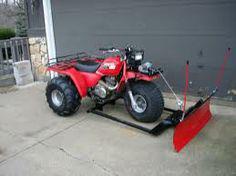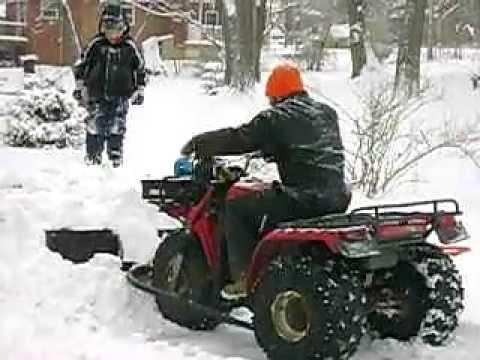The first image is the image on the left, the second image is the image on the right. Evaluate the accuracy of this statement regarding the images: "There is at least one person in the image on the right.". Is it true? Answer yes or no. Yes. 